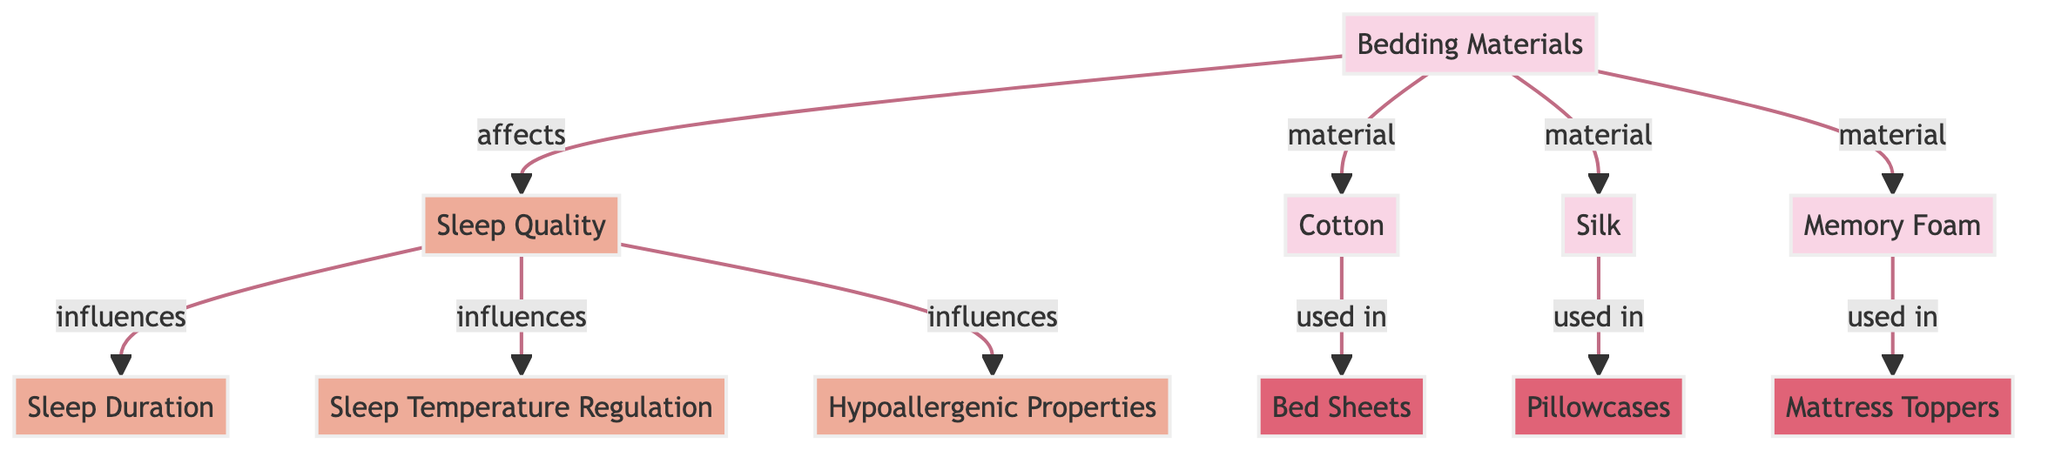What are the three bedding materials listed in the diagram? The diagram shows three bedding materials which are Cotton, Silk, and Memory Foam. These materials are directly connected to the "Bedding Materials" node.
Answer: Cotton, Silk, Memory Foam How many types of bedding materials are represented? There are a total of three types of bedding materials connected to the "Bedding Materials" node: Cotton, Silk, and Memory Foam, which means the count is three.
Answer: Three What does "Bedding Materials" affect according to the diagram? The "Bedding Materials" node has a direct edge that leads to the "Sleep Quality" node, indicating that it affects sleep quality.
Answer: Sleep Quality Which bedding material is used in bed sheets? The diagram indicates that Cotton is used in bed sheets, as per the connection made from the Cotton node to the Bed Sheets node.
Answer: Cotton How many quality factors does sleep quality influence in the diagram? Sleep Quality influences three quality factors: Sleep Duration, Sleep Temperature Regulation, and Hypoallergenic Properties. The edges leading from the Sleep Quality node to these three nodes point to this influence.
Answer: Three Which bedding material is hypoallergenic? The diagram does not specifically mention which bedding material is hypoallergenic, but it implies that bedding quality influences hypoallergenic properties, especially considering memory foam is often associated with hypoallergenic benefits.
Answer: Memory Foam What is the relationship between bedding materials and product usage? The diagram shows that specific bedding materials, like Cotton, Silk, and Memory Foam, are used in different products, connecting these materials to Bed Sheets, Pillowcases, and Mattress Toppers respectively, thereby indicating a material-use relationship.
Answer: Material-Use Relationship Which node directly influences sleep temperature regulation? The diagram demonstrates that Sleep Quality directly influences Sleep Temperature Regulation, establishing a direct connection from the Sleep Quality node to the Sleep Temperature Regulation node.
Answer: Sleep Quality What class do the bedding materials belong to? The bedding materials (Cotton, Silk, Memory Foam) are categorized under "materialNode," which is represented in the diagram with specific styling elements indicating their grouping.
Answer: materialNode 